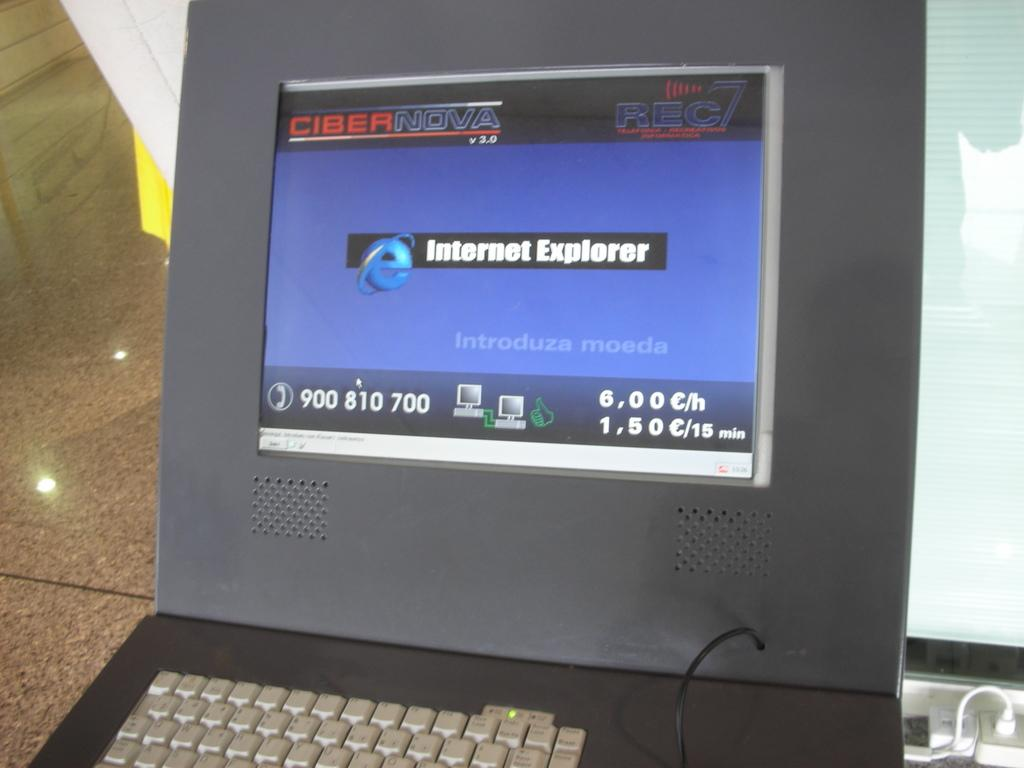<image>
Create a compact narrative representing the image presented. An Internet Explorer screen shows on a small computer monitor. 